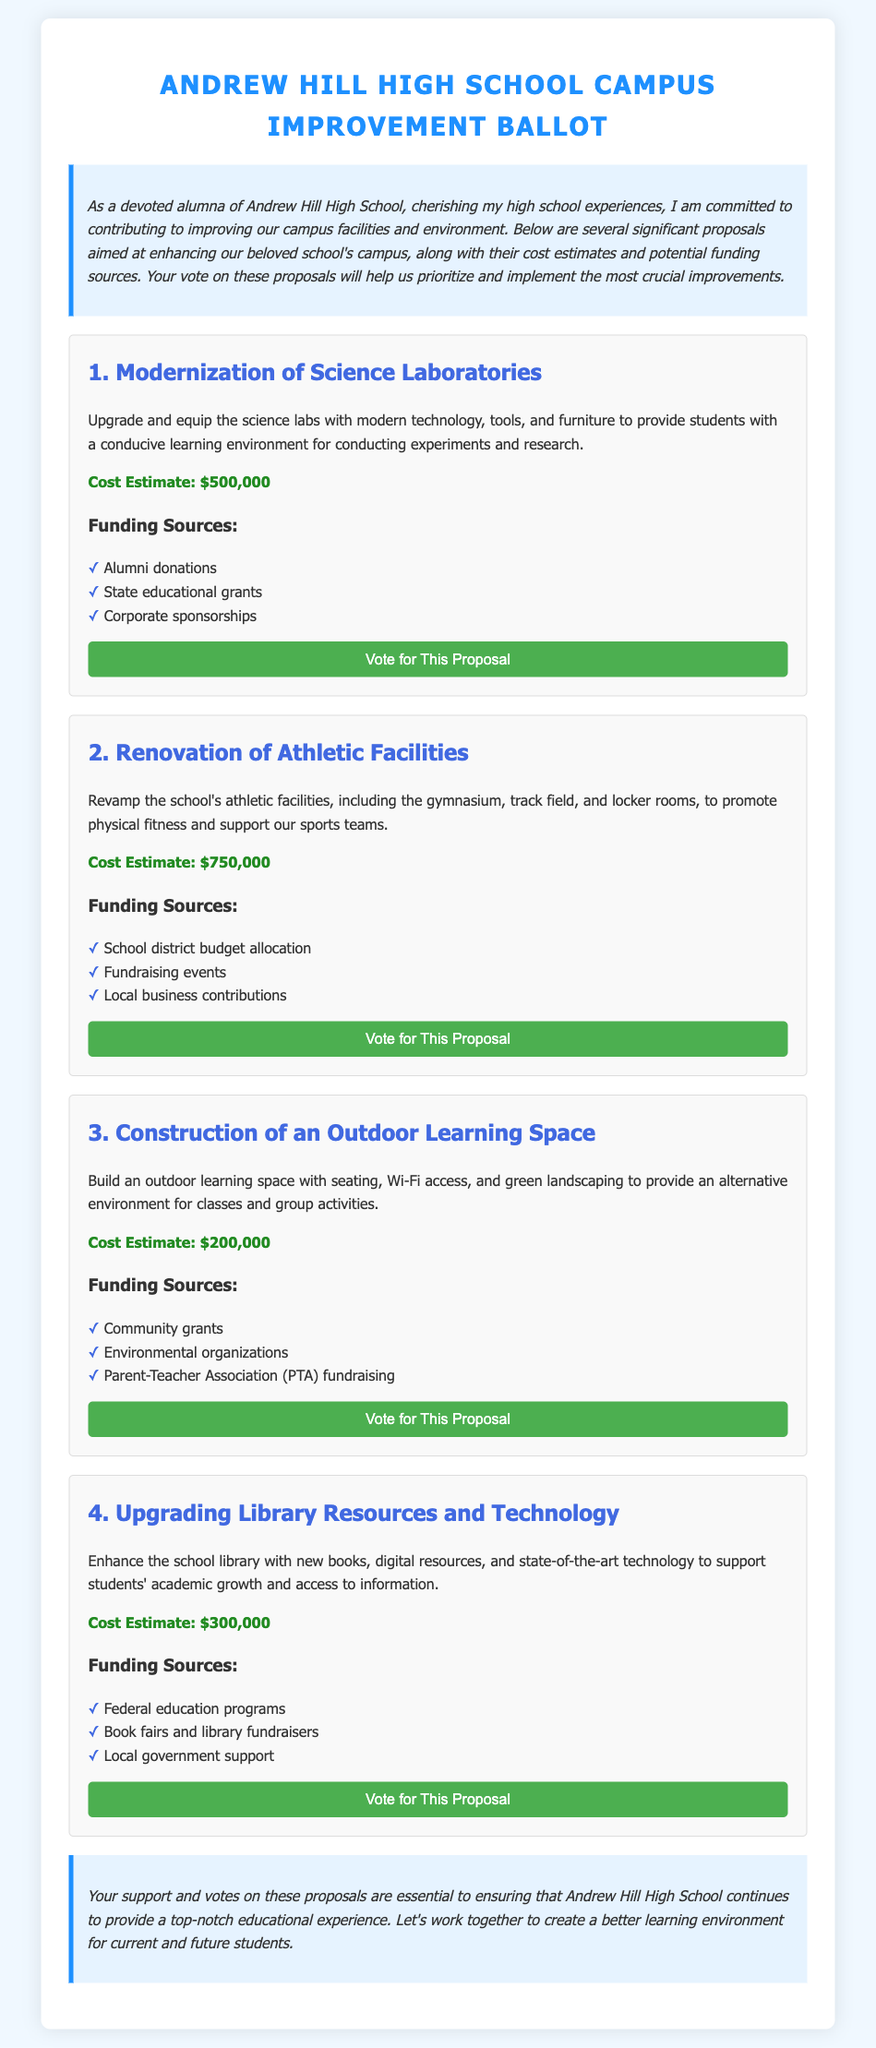what is the cost estimate for the modernization of science laboratories? The cost estimate for this proposal is clearly stated in the document.
Answer: $500,000 what are the funding sources for upgrading library resources and technology? The answer can be found in the respective section of the proposal, listing multiple sources.
Answer: Federal education programs, Book fairs and library fundraisers, Local government support which proposal has the lowest cost estimate? By comparing the cost estimates listed for each proposal, we can identify the one with the lowest amount.
Answer: Construction of an Outdoor Learning Space how many proposals are detailed in the document? The document clearly lists each of the proposals, allowing for a straightforward count.
Answer: 4 what is the main goal of the athletic facilities renovation? The goal is summarized in the proposal description and can be directly referenced.
Answer: Promote physical fitness and support our sports teams which type of funding source is mentioned for the outdoor learning space? This information is specified under the funding sources section of that proposal.
Answer: Community grants who is encouraged to support the proposals? The document indicates who is being called to action in the conclusion.
Answer: Current and future students 